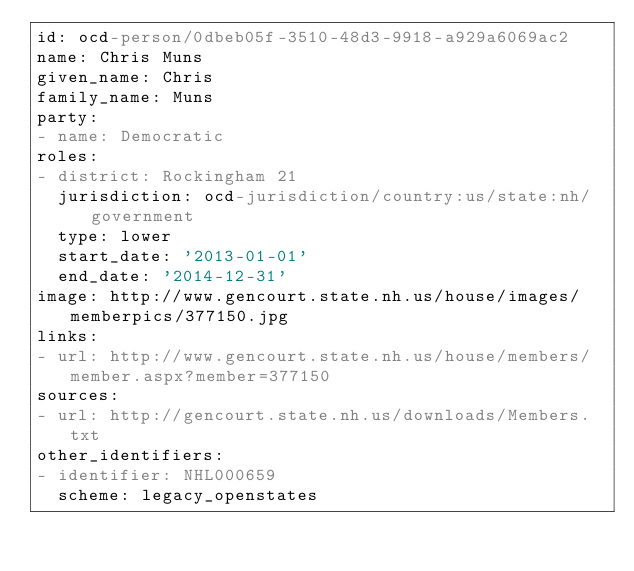Convert code to text. <code><loc_0><loc_0><loc_500><loc_500><_YAML_>id: ocd-person/0dbeb05f-3510-48d3-9918-a929a6069ac2
name: Chris Muns
given_name: Chris
family_name: Muns
party:
- name: Democratic
roles:
- district: Rockingham 21
  jurisdiction: ocd-jurisdiction/country:us/state:nh/government
  type: lower
  start_date: '2013-01-01'
  end_date: '2014-12-31'
image: http://www.gencourt.state.nh.us/house/images/memberpics/377150.jpg
links:
- url: http://www.gencourt.state.nh.us/house/members/member.aspx?member=377150
sources:
- url: http://gencourt.state.nh.us/downloads/Members.txt
other_identifiers:
- identifier: NHL000659
  scheme: legacy_openstates
</code> 